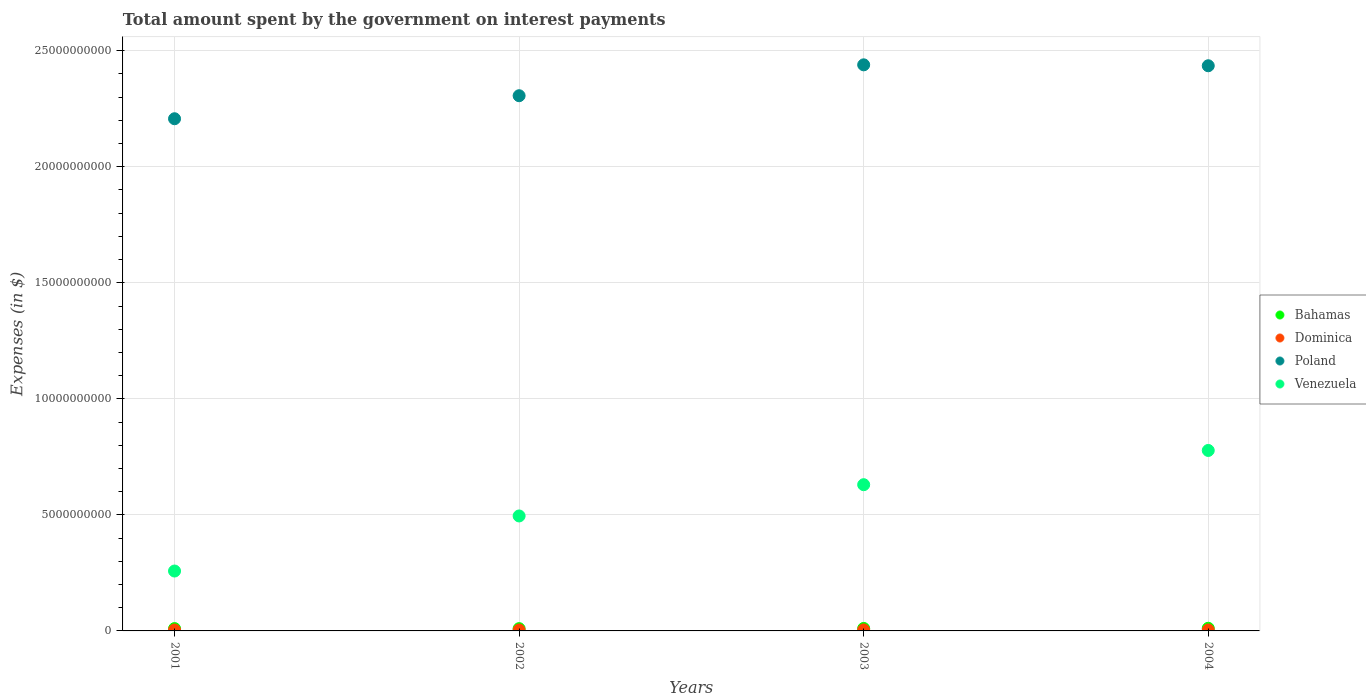What is the amount spent on interest payments by the government in Poland in 2002?
Keep it short and to the point. 2.31e+1. Across all years, what is the maximum amount spent on interest payments by the government in Bahamas?
Offer a terse response. 1.14e+08. Across all years, what is the minimum amount spent on interest payments by the government in Poland?
Your answer should be compact. 2.21e+1. In which year was the amount spent on interest payments by the government in Dominica minimum?
Make the answer very short. 2002. What is the total amount spent on interest payments by the government in Bahamas in the graph?
Make the answer very short. 4.20e+08. What is the difference between the amount spent on interest payments by the government in Venezuela in 2002 and that in 2004?
Give a very brief answer. -2.82e+09. What is the difference between the amount spent on interest payments by the government in Dominica in 2002 and the amount spent on interest payments by the government in Bahamas in 2001?
Your answer should be compact. -6.06e+07. What is the average amount spent on interest payments by the government in Bahamas per year?
Offer a very short reply. 1.05e+08. In the year 2002, what is the difference between the amount spent on interest payments by the government in Venezuela and amount spent on interest payments by the government in Dominica?
Keep it short and to the point. 4.91e+09. What is the ratio of the amount spent on interest payments by the government in Bahamas in 2001 to that in 2004?
Provide a short and direct response. 0.88. Is the difference between the amount spent on interest payments by the government in Venezuela in 2001 and 2003 greater than the difference between the amount spent on interest payments by the government in Dominica in 2001 and 2003?
Keep it short and to the point. No. What is the difference between the highest and the lowest amount spent on interest payments by the government in Bahamas?
Your answer should be compact. 1.56e+07. In how many years, is the amount spent on interest payments by the government in Poland greater than the average amount spent on interest payments by the government in Poland taken over all years?
Make the answer very short. 2. Is the sum of the amount spent on interest payments by the government in Dominica in 2001 and 2004 greater than the maximum amount spent on interest payments by the government in Bahamas across all years?
Ensure brevity in your answer.  No. Is it the case that in every year, the sum of the amount spent on interest payments by the government in Poland and amount spent on interest payments by the government in Venezuela  is greater than the amount spent on interest payments by the government in Dominica?
Your answer should be compact. Yes. Is the amount spent on interest payments by the government in Poland strictly greater than the amount spent on interest payments by the government in Venezuela over the years?
Provide a succinct answer. Yes. How many dotlines are there?
Provide a succinct answer. 4. Does the graph contain grids?
Offer a terse response. Yes. Where does the legend appear in the graph?
Give a very brief answer. Center right. How are the legend labels stacked?
Your answer should be very brief. Vertical. What is the title of the graph?
Provide a short and direct response. Total amount spent by the government on interest payments. What is the label or title of the X-axis?
Ensure brevity in your answer.  Years. What is the label or title of the Y-axis?
Provide a short and direct response. Expenses (in $). What is the Expenses (in $) of Bahamas in 2001?
Provide a short and direct response. 1.01e+08. What is the Expenses (in $) in Dominica in 2001?
Give a very brief answer. 4.02e+07. What is the Expenses (in $) of Poland in 2001?
Ensure brevity in your answer.  2.21e+1. What is the Expenses (in $) of Venezuela in 2001?
Your response must be concise. 2.58e+09. What is the Expenses (in $) of Bahamas in 2002?
Provide a short and direct response. 9.83e+07. What is the Expenses (in $) of Dominica in 2002?
Your answer should be very brief. 4.01e+07. What is the Expenses (in $) in Poland in 2002?
Ensure brevity in your answer.  2.31e+1. What is the Expenses (in $) of Venezuela in 2002?
Offer a terse response. 4.95e+09. What is the Expenses (in $) in Bahamas in 2003?
Ensure brevity in your answer.  1.07e+08. What is the Expenses (in $) of Dominica in 2003?
Your answer should be very brief. 4.46e+07. What is the Expenses (in $) in Poland in 2003?
Ensure brevity in your answer.  2.44e+1. What is the Expenses (in $) of Venezuela in 2003?
Provide a succinct answer. 6.30e+09. What is the Expenses (in $) in Bahamas in 2004?
Offer a terse response. 1.14e+08. What is the Expenses (in $) in Dominica in 2004?
Offer a terse response. 4.16e+07. What is the Expenses (in $) of Poland in 2004?
Your answer should be compact. 2.44e+1. What is the Expenses (in $) in Venezuela in 2004?
Keep it short and to the point. 7.78e+09. Across all years, what is the maximum Expenses (in $) of Bahamas?
Your response must be concise. 1.14e+08. Across all years, what is the maximum Expenses (in $) in Dominica?
Offer a very short reply. 4.46e+07. Across all years, what is the maximum Expenses (in $) in Poland?
Your response must be concise. 2.44e+1. Across all years, what is the maximum Expenses (in $) in Venezuela?
Provide a succinct answer. 7.78e+09. Across all years, what is the minimum Expenses (in $) in Bahamas?
Give a very brief answer. 9.83e+07. Across all years, what is the minimum Expenses (in $) in Dominica?
Provide a short and direct response. 4.01e+07. Across all years, what is the minimum Expenses (in $) in Poland?
Provide a short and direct response. 2.21e+1. Across all years, what is the minimum Expenses (in $) in Venezuela?
Provide a succinct answer. 2.58e+09. What is the total Expenses (in $) of Bahamas in the graph?
Offer a terse response. 4.20e+08. What is the total Expenses (in $) of Dominica in the graph?
Offer a terse response. 1.66e+08. What is the total Expenses (in $) in Poland in the graph?
Keep it short and to the point. 9.39e+1. What is the total Expenses (in $) of Venezuela in the graph?
Ensure brevity in your answer.  2.16e+1. What is the difference between the Expenses (in $) of Bahamas in 2001 and that in 2002?
Keep it short and to the point. 2.40e+06. What is the difference between the Expenses (in $) in Poland in 2001 and that in 2002?
Provide a short and direct response. -9.92e+08. What is the difference between the Expenses (in $) in Venezuela in 2001 and that in 2002?
Make the answer very short. -2.37e+09. What is the difference between the Expenses (in $) of Bahamas in 2001 and that in 2003?
Give a very brief answer. -6.30e+06. What is the difference between the Expenses (in $) in Dominica in 2001 and that in 2003?
Offer a very short reply. -4.40e+06. What is the difference between the Expenses (in $) of Poland in 2001 and that in 2003?
Your answer should be compact. -2.32e+09. What is the difference between the Expenses (in $) of Venezuela in 2001 and that in 2003?
Provide a succinct answer. -3.72e+09. What is the difference between the Expenses (in $) of Bahamas in 2001 and that in 2004?
Your answer should be compact. -1.32e+07. What is the difference between the Expenses (in $) of Dominica in 2001 and that in 2004?
Your response must be concise. -1.40e+06. What is the difference between the Expenses (in $) of Poland in 2001 and that in 2004?
Offer a terse response. -2.28e+09. What is the difference between the Expenses (in $) in Venezuela in 2001 and that in 2004?
Provide a succinct answer. -5.20e+09. What is the difference between the Expenses (in $) in Bahamas in 2002 and that in 2003?
Your answer should be very brief. -8.70e+06. What is the difference between the Expenses (in $) of Dominica in 2002 and that in 2003?
Provide a succinct answer. -4.50e+06. What is the difference between the Expenses (in $) in Poland in 2002 and that in 2003?
Give a very brief answer. -1.33e+09. What is the difference between the Expenses (in $) in Venezuela in 2002 and that in 2003?
Provide a succinct answer. -1.35e+09. What is the difference between the Expenses (in $) in Bahamas in 2002 and that in 2004?
Your answer should be compact. -1.56e+07. What is the difference between the Expenses (in $) in Dominica in 2002 and that in 2004?
Provide a short and direct response. -1.50e+06. What is the difference between the Expenses (in $) in Poland in 2002 and that in 2004?
Give a very brief answer. -1.29e+09. What is the difference between the Expenses (in $) in Venezuela in 2002 and that in 2004?
Your answer should be very brief. -2.82e+09. What is the difference between the Expenses (in $) of Bahamas in 2003 and that in 2004?
Give a very brief answer. -6.94e+06. What is the difference between the Expenses (in $) in Dominica in 2003 and that in 2004?
Give a very brief answer. 3.00e+06. What is the difference between the Expenses (in $) in Poland in 2003 and that in 2004?
Give a very brief answer. 4.00e+07. What is the difference between the Expenses (in $) of Venezuela in 2003 and that in 2004?
Your answer should be very brief. -1.48e+09. What is the difference between the Expenses (in $) of Bahamas in 2001 and the Expenses (in $) of Dominica in 2002?
Give a very brief answer. 6.06e+07. What is the difference between the Expenses (in $) in Bahamas in 2001 and the Expenses (in $) in Poland in 2002?
Make the answer very short. -2.30e+1. What is the difference between the Expenses (in $) of Bahamas in 2001 and the Expenses (in $) of Venezuela in 2002?
Give a very brief answer. -4.85e+09. What is the difference between the Expenses (in $) of Dominica in 2001 and the Expenses (in $) of Poland in 2002?
Make the answer very short. -2.30e+1. What is the difference between the Expenses (in $) in Dominica in 2001 and the Expenses (in $) in Venezuela in 2002?
Offer a very short reply. -4.91e+09. What is the difference between the Expenses (in $) in Poland in 2001 and the Expenses (in $) in Venezuela in 2002?
Offer a terse response. 1.71e+1. What is the difference between the Expenses (in $) of Bahamas in 2001 and the Expenses (in $) of Dominica in 2003?
Your answer should be very brief. 5.61e+07. What is the difference between the Expenses (in $) in Bahamas in 2001 and the Expenses (in $) in Poland in 2003?
Your answer should be very brief. -2.43e+1. What is the difference between the Expenses (in $) of Bahamas in 2001 and the Expenses (in $) of Venezuela in 2003?
Keep it short and to the point. -6.20e+09. What is the difference between the Expenses (in $) of Dominica in 2001 and the Expenses (in $) of Poland in 2003?
Offer a very short reply. -2.44e+1. What is the difference between the Expenses (in $) of Dominica in 2001 and the Expenses (in $) of Venezuela in 2003?
Your answer should be compact. -6.26e+09. What is the difference between the Expenses (in $) in Poland in 2001 and the Expenses (in $) in Venezuela in 2003?
Your response must be concise. 1.58e+1. What is the difference between the Expenses (in $) in Bahamas in 2001 and the Expenses (in $) in Dominica in 2004?
Ensure brevity in your answer.  5.91e+07. What is the difference between the Expenses (in $) of Bahamas in 2001 and the Expenses (in $) of Poland in 2004?
Keep it short and to the point. -2.43e+1. What is the difference between the Expenses (in $) of Bahamas in 2001 and the Expenses (in $) of Venezuela in 2004?
Your answer should be very brief. -7.68e+09. What is the difference between the Expenses (in $) in Dominica in 2001 and the Expenses (in $) in Poland in 2004?
Offer a terse response. -2.43e+1. What is the difference between the Expenses (in $) of Dominica in 2001 and the Expenses (in $) of Venezuela in 2004?
Your answer should be compact. -7.74e+09. What is the difference between the Expenses (in $) of Poland in 2001 and the Expenses (in $) of Venezuela in 2004?
Keep it short and to the point. 1.43e+1. What is the difference between the Expenses (in $) in Bahamas in 2002 and the Expenses (in $) in Dominica in 2003?
Ensure brevity in your answer.  5.37e+07. What is the difference between the Expenses (in $) in Bahamas in 2002 and the Expenses (in $) in Poland in 2003?
Offer a terse response. -2.43e+1. What is the difference between the Expenses (in $) of Bahamas in 2002 and the Expenses (in $) of Venezuela in 2003?
Keep it short and to the point. -6.20e+09. What is the difference between the Expenses (in $) of Dominica in 2002 and the Expenses (in $) of Poland in 2003?
Offer a terse response. -2.44e+1. What is the difference between the Expenses (in $) of Dominica in 2002 and the Expenses (in $) of Venezuela in 2003?
Your answer should be compact. -6.26e+09. What is the difference between the Expenses (in $) in Poland in 2002 and the Expenses (in $) in Venezuela in 2003?
Give a very brief answer. 1.68e+1. What is the difference between the Expenses (in $) of Bahamas in 2002 and the Expenses (in $) of Dominica in 2004?
Your answer should be very brief. 5.67e+07. What is the difference between the Expenses (in $) in Bahamas in 2002 and the Expenses (in $) in Poland in 2004?
Your answer should be compact. -2.43e+1. What is the difference between the Expenses (in $) in Bahamas in 2002 and the Expenses (in $) in Venezuela in 2004?
Keep it short and to the point. -7.68e+09. What is the difference between the Expenses (in $) of Dominica in 2002 and the Expenses (in $) of Poland in 2004?
Your answer should be compact. -2.43e+1. What is the difference between the Expenses (in $) of Dominica in 2002 and the Expenses (in $) of Venezuela in 2004?
Give a very brief answer. -7.74e+09. What is the difference between the Expenses (in $) of Poland in 2002 and the Expenses (in $) of Venezuela in 2004?
Provide a succinct answer. 1.53e+1. What is the difference between the Expenses (in $) of Bahamas in 2003 and the Expenses (in $) of Dominica in 2004?
Offer a very short reply. 6.54e+07. What is the difference between the Expenses (in $) of Bahamas in 2003 and the Expenses (in $) of Poland in 2004?
Make the answer very short. -2.42e+1. What is the difference between the Expenses (in $) in Bahamas in 2003 and the Expenses (in $) in Venezuela in 2004?
Offer a terse response. -7.67e+09. What is the difference between the Expenses (in $) in Dominica in 2003 and the Expenses (in $) in Poland in 2004?
Offer a terse response. -2.43e+1. What is the difference between the Expenses (in $) in Dominica in 2003 and the Expenses (in $) in Venezuela in 2004?
Ensure brevity in your answer.  -7.73e+09. What is the difference between the Expenses (in $) in Poland in 2003 and the Expenses (in $) in Venezuela in 2004?
Keep it short and to the point. 1.66e+1. What is the average Expenses (in $) in Bahamas per year?
Provide a short and direct response. 1.05e+08. What is the average Expenses (in $) in Dominica per year?
Your answer should be very brief. 4.16e+07. What is the average Expenses (in $) in Poland per year?
Your answer should be very brief. 2.35e+1. What is the average Expenses (in $) in Venezuela per year?
Offer a terse response. 5.40e+09. In the year 2001, what is the difference between the Expenses (in $) of Bahamas and Expenses (in $) of Dominica?
Your response must be concise. 6.05e+07. In the year 2001, what is the difference between the Expenses (in $) in Bahamas and Expenses (in $) in Poland?
Ensure brevity in your answer.  -2.20e+1. In the year 2001, what is the difference between the Expenses (in $) of Bahamas and Expenses (in $) of Venezuela?
Your answer should be compact. -2.48e+09. In the year 2001, what is the difference between the Expenses (in $) in Dominica and Expenses (in $) in Poland?
Your answer should be compact. -2.20e+1. In the year 2001, what is the difference between the Expenses (in $) of Dominica and Expenses (in $) of Venezuela?
Make the answer very short. -2.54e+09. In the year 2001, what is the difference between the Expenses (in $) of Poland and Expenses (in $) of Venezuela?
Your response must be concise. 1.95e+1. In the year 2002, what is the difference between the Expenses (in $) of Bahamas and Expenses (in $) of Dominica?
Ensure brevity in your answer.  5.82e+07. In the year 2002, what is the difference between the Expenses (in $) of Bahamas and Expenses (in $) of Poland?
Give a very brief answer. -2.30e+1. In the year 2002, what is the difference between the Expenses (in $) of Bahamas and Expenses (in $) of Venezuela?
Keep it short and to the point. -4.86e+09. In the year 2002, what is the difference between the Expenses (in $) of Dominica and Expenses (in $) of Poland?
Give a very brief answer. -2.30e+1. In the year 2002, what is the difference between the Expenses (in $) of Dominica and Expenses (in $) of Venezuela?
Make the answer very short. -4.91e+09. In the year 2002, what is the difference between the Expenses (in $) in Poland and Expenses (in $) in Venezuela?
Give a very brief answer. 1.81e+1. In the year 2003, what is the difference between the Expenses (in $) in Bahamas and Expenses (in $) in Dominica?
Your response must be concise. 6.24e+07. In the year 2003, what is the difference between the Expenses (in $) of Bahamas and Expenses (in $) of Poland?
Your answer should be very brief. -2.43e+1. In the year 2003, what is the difference between the Expenses (in $) in Bahamas and Expenses (in $) in Venezuela?
Your response must be concise. -6.19e+09. In the year 2003, what is the difference between the Expenses (in $) of Dominica and Expenses (in $) of Poland?
Your answer should be very brief. -2.43e+1. In the year 2003, what is the difference between the Expenses (in $) of Dominica and Expenses (in $) of Venezuela?
Your answer should be very brief. -6.26e+09. In the year 2003, what is the difference between the Expenses (in $) in Poland and Expenses (in $) in Venezuela?
Offer a very short reply. 1.81e+1. In the year 2004, what is the difference between the Expenses (in $) in Bahamas and Expenses (in $) in Dominica?
Ensure brevity in your answer.  7.23e+07. In the year 2004, what is the difference between the Expenses (in $) of Bahamas and Expenses (in $) of Poland?
Your response must be concise. -2.42e+1. In the year 2004, what is the difference between the Expenses (in $) in Bahamas and Expenses (in $) in Venezuela?
Provide a short and direct response. -7.66e+09. In the year 2004, what is the difference between the Expenses (in $) in Dominica and Expenses (in $) in Poland?
Your answer should be very brief. -2.43e+1. In the year 2004, what is the difference between the Expenses (in $) in Dominica and Expenses (in $) in Venezuela?
Ensure brevity in your answer.  -7.73e+09. In the year 2004, what is the difference between the Expenses (in $) of Poland and Expenses (in $) of Venezuela?
Your answer should be compact. 1.66e+1. What is the ratio of the Expenses (in $) of Bahamas in 2001 to that in 2002?
Give a very brief answer. 1.02. What is the ratio of the Expenses (in $) of Poland in 2001 to that in 2002?
Your answer should be very brief. 0.96. What is the ratio of the Expenses (in $) in Venezuela in 2001 to that in 2002?
Your answer should be compact. 0.52. What is the ratio of the Expenses (in $) of Bahamas in 2001 to that in 2003?
Make the answer very short. 0.94. What is the ratio of the Expenses (in $) of Dominica in 2001 to that in 2003?
Offer a terse response. 0.9. What is the ratio of the Expenses (in $) of Poland in 2001 to that in 2003?
Your answer should be very brief. 0.9. What is the ratio of the Expenses (in $) of Venezuela in 2001 to that in 2003?
Offer a very short reply. 0.41. What is the ratio of the Expenses (in $) of Bahamas in 2001 to that in 2004?
Provide a short and direct response. 0.88. What is the ratio of the Expenses (in $) in Dominica in 2001 to that in 2004?
Offer a very short reply. 0.97. What is the ratio of the Expenses (in $) of Poland in 2001 to that in 2004?
Keep it short and to the point. 0.91. What is the ratio of the Expenses (in $) of Venezuela in 2001 to that in 2004?
Make the answer very short. 0.33. What is the ratio of the Expenses (in $) of Bahamas in 2002 to that in 2003?
Give a very brief answer. 0.92. What is the ratio of the Expenses (in $) in Dominica in 2002 to that in 2003?
Provide a short and direct response. 0.9. What is the ratio of the Expenses (in $) of Poland in 2002 to that in 2003?
Give a very brief answer. 0.95. What is the ratio of the Expenses (in $) in Venezuela in 2002 to that in 2003?
Your response must be concise. 0.79. What is the ratio of the Expenses (in $) in Bahamas in 2002 to that in 2004?
Offer a very short reply. 0.86. What is the ratio of the Expenses (in $) in Dominica in 2002 to that in 2004?
Offer a very short reply. 0.96. What is the ratio of the Expenses (in $) in Poland in 2002 to that in 2004?
Offer a very short reply. 0.95. What is the ratio of the Expenses (in $) of Venezuela in 2002 to that in 2004?
Provide a short and direct response. 0.64. What is the ratio of the Expenses (in $) of Bahamas in 2003 to that in 2004?
Ensure brevity in your answer.  0.94. What is the ratio of the Expenses (in $) of Dominica in 2003 to that in 2004?
Ensure brevity in your answer.  1.07. What is the ratio of the Expenses (in $) in Venezuela in 2003 to that in 2004?
Your answer should be compact. 0.81. What is the difference between the highest and the second highest Expenses (in $) in Bahamas?
Ensure brevity in your answer.  6.94e+06. What is the difference between the highest and the second highest Expenses (in $) of Dominica?
Ensure brevity in your answer.  3.00e+06. What is the difference between the highest and the second highest Expenses (in $) in Poland?
Ensure brevity in your answer.  4.00e+07. What is the difference between the highest and the second highest Expenses (in $) in Venezuela?
Ensure brevity in your answer.  1.48e+09. What is the difference between the highest and the lowest Expenses (in $) in Bahamas?
Ensure brevity in your answer.  1.56e+07. What is the difference between the highest and the lowest Expenses (in $) in Dominica?
Keep it short and to the point. 4.50e+06. What is the difference between the highest and the lowest Expenses (in $) of Poland?
Your answer should be compact. 2.32e+09. What is the difference between the highest and the lowest Expenses (in $) of Venezuela?
Your answer should be compact. 5.20e+09. 